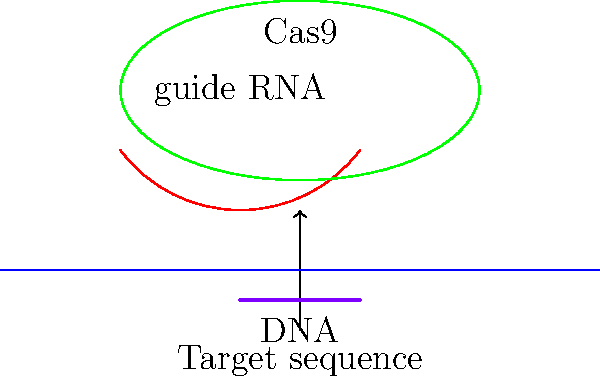In the CRISPR-Cas9 gene editing process illustrated above, what is the primary function of the guide RNA, and how does it contribute to the specificity of the genetic modification? To understand the function of guide RNA in the CRISPR-Cas9 gene editing process, let's break it down step-by-step:

1. CRISPR-Cas9 system components:
   a. Cas9 enzyme (green ellipse in the diagram)
   b. Guide RNA (red curved line)
   c. Target DNA (blue straight line)

2. Guide RNA function:
   a. The guide RNA is a short RNA sequence designed to complement the target DNA sequence.
   b. It acts as a "guide" for the Cas9 enzyme, directing it to the specific location on the DNA where the edit should occur.

3. Specificity mechanism:
   a. The guide RNA base-pairs with the complementary DNA sequence.
   b. This base-pairing is highly specific, ensuring that the Cas9 enzyme only cuts at the intended location.

4. Cas9 activation:
   a. Once the guide RNA finds its complementary sequence on the target DNA, it binds to it.
   b. This binding triggers the Cas9 enzyme to make a double-stranded break in the DNA at the specified location.

5. Genetic modification:
   a. After the DNA is cut, the cell's natural repair mechanisms take over.
   b. These repair mechanisms can be exploited to insert, delete, or modify genes at the cut site.

In summary, the guide RNA provides a precise targeting mechanism for the Cas9 enzyme, ensuring that genetic modifications occur only at the intended location in the genome. This specificity is crucial for accurate and safe gene editing.
Answer: The guide RNA directs Cas9 to the specific DNA target sequence, ensuring precise gene editing. 